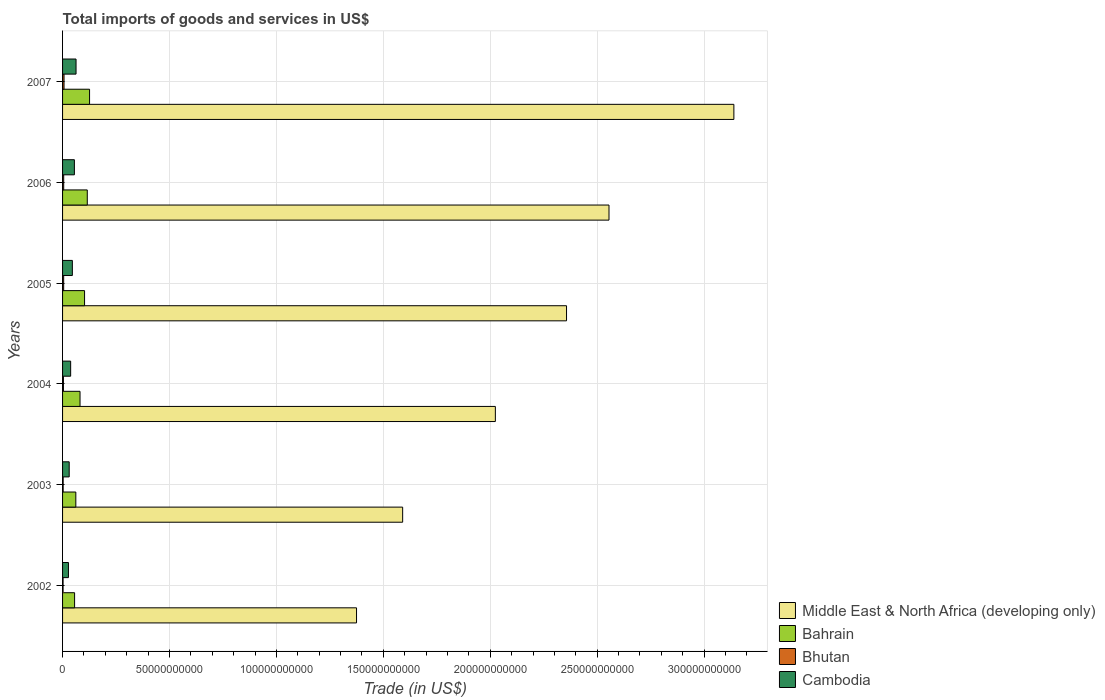How many different coloured bars are there?
Provide a succinct answer. 4. Are the number of bars on each tick of the Y-axis equal?
Your answer should be compact. Yes. How many bars are there on the 1st tick from the top?
Keep it short and to the point. 4. What is the label of the 3rd group of bars from the top?
Make the answer very short. 2005. In how many cases, is the number of bars for a given year not equal to the number of legend labels?
Your response must be concise. 0. What is the total imports of goods and services in Bahrain in 2003?
Offer a very short reply. 6.21e+09. Across all years, what is the maximum total imports of goods and services in Bhutan?
Provide a succinct answer. 6.85e+08. Across all years, what is the minimum total imports of goods and services in Bahrain?
Provide a succinct answer. 5.62e+09. In which year was the total imports of goods and services in Middle East & North Africa (developing only) maximum?
Offer a very short reply. 2007. What is the total total imports of goods and services in Middle East & North Africa (developing only) in the graph?
Your answer should be compact. 1.30e+12. What is the difference between the total imports of goods and services in Cambodia in 2005 and that in 2007?
Your answer should be very brief. -1.72e+09. What is the difference between the total imports of goods and services in Bahrain in 2006 and the total imports of goods and services in Cambodia in 2003?
Make the answer very short. 8.46e+09. What is the average total imports of goods and services in Bahrain per year?
Your answer should be very brief. 9.08e+09. In the year 2005, what is the difference between the total imports of goods and services in Bhutan and total imports of goods and services in Bahrain?
Offer a very short reply. -9.77e+09. What is the ratio of the total imports of goods and services in Cambodia in 2003 to that in 2005?
Ensure brevity in your answer.  0.68. Is the total imports of goods and services in Cambodia in 2002 less than that in 2003?
Provide a succinct answer. Yes. Is the difference between the total imports of goods and services in Bhutan in 2002 and 2006 greater than the difference between the total imports of goods and services in Bahrain in 2002 and 2006?
Your answer should be very brief. Yes. What is the difference between the highest and the second highest total imports of goods and services in Middle East & North Africa (developing only)?
Provide a succinct answer. 5.84e+1. What is the difference between the highest and the lowest total imports of goods and services in Bahrain?
Ensure brevity in your answer.  7.00e+09. In how many years, is the total imports of goods and services in Bhutan greater than the average total imports of goods and services in Bhutan taken over all years?
Provide a short and direct response. 3. Is the sum of the total imports of goods and services in Middle East & North Africa (developing only) in 2002 and 2006 greater than the maximum total imports of goods and services in Bhutan across all years?
Offer a very short reply. Yes. What does the 3rd bar from the top in 2006 represents?
Provide a short and direct response. Bahrain. What does the 1st bar from the bottom in 2006 represents?
Your response must be concise. Middle East & North Africa (developing only). Are all the bars in the graph horizontal?
Offer a very short reply. Yes. What is the difference between two consecutive major ticks on the X-axis?
Give a very brief answer. 5.00e+1. Are the values on the major ticks of X-axis written in scientific E-notation?
Ensure brevity in your answer.  No. Does the graph contain any zero values?
Your response must be concise. No. How many legend labels are there?
Give a very brief answer. 4. How are the legend labels stacked?
Your answer should be compact. Vertical. What is the title of the graph?
Your answer should be compact. Total imports of goods and services in US$. Does "Belarus" appear as one of the legend labels in the graph?
Your response must be concise. No. What is the label or title of the X-axis?
Provide a short and direct response. Trade (in US$). What is the Trade (in US$) of Middle East & North Africa (developing only) in 2002?
Give a very brief answer. 1.37e+11. What is the Trade (in US$) in Bahrain in 2002?
Your response must be concise. 5.62e+09. What is the Trade (in US$) in Bhutan in 2002?
Give a very brief answer. 2.40e+08. What is the Trade (in US$) of Cambodia in 2002?
Give a very brief answer. 2.75e+09. What is the Trade (in US$) of Middle East & North Africa (developing only) in 2003?
Offer a terse response. 1.59e+11. What is the Trade (in US$) of Bahrain in 2003?
Offer a terse response. 6.21e+09. What is the Trade (in US$) in Bhutan in 2003?
Provide a succinct answer. 2.75e+08. What is the Trade (in US$) of Cambodia in 2003?
Ensure brevity in your answer.  3.10e+09. What is the Trade (in US$) in Middle East & North Africa (developing only) in 2004?
Your answer should be very brief. 2.02e+11. What is the Trade (in US$) in Bahrain in 2004?
Give a very brief answer. 8.17e+09. What is the Trade (in US$) in Bhutan in 2004?
Your answer should be very brief. 4.06e+08. What is the Trade (in US$) of Cambodia in 2004?
Offer a terse response. 3.78e+09. What is the Trade (in US$) in Middle East & North Africa (developing only) in 2005?
Your answer should be compact. 2.36e+11. What is the Trade (in US$) of Bahrain in 2005?
Offer a terse response. 1.03e+1. What is the Trade (in US$) in Bhutan in 2005?
Offer a very short reply. 5.15e+08. What is the Trade (in US$) of Cambodia in 2005?
Give a very brief answer. 4.58e+09. What is the Trade (in US$) of Middle East & North Africa (developing only) in 2006?
Your response must be concise. 2.56e+11. What is the Trade (in US$) in Bahrain in 2006?
Your answer should be compact. 1.16e+1. What is the Trade (in US$) in Bhutan in 2006?
Provide a succinct answer. 5.31e+08. What is the Trade (in US$) in Cambodia in 2006?
Provide a succinct answer. 5.53e+09. What is the Trade (in US$) in Middle East & North Africa (developing only) in 2007?
Ensure brevity in your answer.  3.14e+11. What is the Trade (in US$) in Bahrain in 2007?
Make the answer very short. 1.26e+1. What is the Trade (in US$) of Bhutan in 2007?
Ensure brevity in your answer.  6.85e+08. What is the Trade (in US$) in Cambodia in 2007?
Your answer should be compact. 6.30e+09. Across all years, what is the maximum Trade (in US$) in Middle East & North Africa (developing only)?
Offer a very short reply. 3.14e+11. Across all years, what is the maximum Trade (in US$) in Bahrain?
Ensure brevity in your answer.  1.26e+1. Across all years, what is the maximum Trade (in US$) of Bhutan?
Offer a very short reply. 6.85e+08. Across all years, what is the maximum Trade (in US$) of Cambodia?
Keep it short and to the point. 6.30e+09. Across all years, what is the minimum Trade (in US$) of Middle East & North Africa (developing only)?
Your answer should be very brief. 1.37e+11. Across all years, what is the minimum Trade (in US$) in Bahrain?
Your response must be concise. 5.62e+09. Across all years, what is the minimum Trade (in US$) of Bhutan?
Give a very brief answer. 2.40e+08. Across all years, what is the minimum Trade (in US$) of Cambodia?
Keep it short and to the point. 2.75e+09. What is the total Trade (in US$) of Middle East & North Africa (developing only) in the graph?
Your answer should be very brief. 1.30e+12. What is the total Trade (in US$) of Bahrain in the graph?
Your response must be concise. 5.45e+1. What is the total Trade (in US$) of Bhutan in the graph?
Keep it short and to the point. 2.65e+09. What is the total Trade (in US$) of Cambodia in the graph?
Your answer should be very brief. 2.60e+1. What is the difference between the Trade (in US$) of Middle East & North Africa (developing only) in 2002 and that in 2003?
Offer a terse response. -2.16e+1. What is the difference between the Trade (in US$) in Bahrain in 2002 and that in 2003?
Offer a terse response. -5.81e+08. What is the difference between the Trade (in US$) of Bhutan in 2002 and that in 2003?
Offer a terse response. -3.50e+07. What is the difference between the Trade (in US$) of Cambodia in 2002 and that in 2003?
Make the answer very short. -3.47e+08. What is the difference between the Trade (in US$) in Middle East & North Africa (developing only) in 2002 and that in 2004?
Offer a terse response. -6.49e+1. What is the difference between the Trade (in US$) in Bahrain in 2002 and that in 2004?
Ensure brevity in your answer.  -2.55e+09. What is the difference between the Trade (in US$) in Bhutan in 2002 and that in 2004?
Offer a very short reply. -1.66e+08. What is the difference between the Trade (in US$) of Cambodia in 2002 and that in 2004?
Make the answer very short. -1.03e+09. What is the difference between the Trade (in US$) of Middle East & North Africa (developing only) in 2002 and that in 2005?
Keep it short and to the point. -9.82e+1. What is the difference between the Trade (in US$) in Bahrain in 2002 and that in 2005?
Your answer should be very brief. -4.66e+09. What is the difference between the Trade (in US$) in Bhutan in 2002 and that in 2005?
Offer a very short reply. -2.76e+08. What is the difference between the Trade (in US$) in Cambodia in 2002 and that in 2005?
Offer a terse response. -1.82e+09. What is the difference between the Trade (in US$) in Middle East & North Africa (developing only) in 2002 and that in 2006?
Your response must be concise. -1.18e+11. What is the difference between the Trade (in US$) in Bahrain in 2002 and that in 2006?
Offer a terse response. -5.93e+09. What is the difference between the Trade (in US$) in Bhutan in 2002 and that in 2006?
Keep it short and to the point. -2.92e+08. What is the difference between the Trade (in US$) in Cambodia in 2002 and that in 2006?
Keep it short and to the point. -2.78e+09. What is the difference between the Trade (in US$) in Middle East & North Africa (developing only) in 2002 and that in 2007?
Your response must be concise. -1.76e+11. What is the difference between the Trade (in US$) in Bahrain in 2002 and that in 2007?
Offer a terse response. -7.00e+09. What is the difference between the Trade (in US$) of Bhutan in 2002 and that in 2007?
Make the answer very short. -4.45e+08. What is the difference between the Trade (in US$) in Cambodia in 2002 and that in 2007?
Your response must be concise. -3.55e+09. What is the difference between the Trade (in US$) of Middle East & North Africa (developing only) in 2003 and that in 2004?
Make the answer very short. -4.34e+1. What is the difference between the Trade (in US$) in Bahrain in 2003 and that in 2004?
Your answer should be compact. -1.97e+09. What is the difference between the Trade (in US$) of Bhutan in 2003 and that in 2004?
Provide a succinct answer. -1.31e+08. What is the difference between the Trade (in US$) in Cambodia in 2003 and that in 2004?
Ensure brevity in your answer.  -6.84e+08. What is the difference between the Trade (in US$) in Middle East & North Africa (developing only) in 2003 and that in 2005?
Give a very brief answer. -7.66e+1. What is the difference between the Trade (in US$) of Bahrain in 2003 and that in 2005?
Your response must be concise. -4.08e+09. What is the difference between the Trade (in US$) in Bhutan in 2003 and that in 2005?
Your answer should be very brief. -2.41e+08. What is the difference between the Trade (in US$) in Cambodia in 2003 and that in 2005?
Offer a terse response. -1.48e+09. What is the difference between the Trade (in US$) in Middle East & North Africa (developing only) in 2003 and that in 2006?
Offer a very short reply. -9.65e+1. What is the difference between the Trade (in US$) of Bahrain in 2003 and that in 2006?
Provide a short and direct response. -5.35e+09. What is the difference between the Trade (in US$) of Bhutan in 2003 and that in 2006?
Provide a short and direct response. -2.57e+08. What is the difference between the Trade (in US$) of Cambodia in 2003 and that in 2006?
Offer a very short reply. -2.43e+09. What is the difference between the Trade (in US$) in Middle East & North Africa (developing only) in 2003 and that in 2007?
Keep it short and to the point. -1.55e+11. What is the difference between the Trade (in US$) in Bahrain in 2003 and that in 2007?
Provide a short and direct response. -6.42e+09. What is the difference between the Trade (in US$) of Bhutan in 2003 and that in 2007?
Give a very brief answer. -4.10e+08. What is the difference between the Trade (in US$) of Cambodia in 2003 and that in 2007?
Keep it short and to the point. -3.20e+09. What is the difference between the Trade (in US$) in Middle East & North Africa (developing only) in 2004 and that in 2005?
Give a very brief answer. -3.33e+1. What is the difference between the Trade (in US$) of Bahrain in 2004 and that in 2005?
Offer a terse response. -2.12e+09. What is the difference between the Trade (in US$) in Bhutan in 2004 and that in 2005?
Ensure brevity in your answer.  -1.09e+08. What is the difference between the Trade (in US$) of Cambodia in 2004 and that in 2005?
Ensure brevity in your answer.  -7.93e+08. What is the difference between the Trade (in US$) of Middle East & North Africa (developing only) in 2004 and that in 2006?
Make the answer very short. -5.31e+1. What is the difference between the Trade (in US$) in Bahrain in 2004 and that in 2006?
Keep it short and to the point. -3.39e+09. What is the difference between the Trade (in US$) in Bhutan in 2004 and that in 2006?
Give a very brief answer. -1.25e+08. What is the difference between the Trade (in US$) of Cambodia in 2004 and that in 2006?
Your answer should be compact. -1.75e+09. What is the difference between the Trade (in US$) in Middle East & North Africa (developing only) in 2004 and that in 2007?
Your response must be concise. -1.12e+11. What is the difference between the Trade (in US$) of Bahrain in 2004 and that in 2007?
Provide a short and direct response. -4.46e+09. What is the difference between the Trade (in US$) of Bhutan in 2004 and that in 2007?
Your answer should be very brief. -2.79e+08. What is the difference between the Trade (in US$) in Cambodia in 2004 and that in 2007?
Ensure brevity in your answer.  -2.52e+09. What is the difference between the Trade (in US$) in Middle East & North Africa (developing only) in 2005 and that in 2006?
Ensure brevity in your answer.  -1.99e+1. What is the difference between the Trade (in US$) of Bahrain in 2005 and that in 2006?
Your answer should be compact. -1.27e+09. What is the difference between the Trade (in US$) in Bhutan in 2005 and that in 2006?
Give a very brief answer. -1.60e+07. What is the difference between the Trade (in US$) in Cambodia in 2005 and that in 2006?
Offer a very short reply. -9.52e+08. What is the difference between the Trade (in US$) in Middle East & North Africa (developing only) in 2005 and that in 2007?
Provide a short and direct response. -7.83e+1. What is the difference between the Trade (in US$) of Bahrain in 2005 and that in 2007?
Offer a very short reply. -2.34e+09. What is the difference between the Trade (in US$) in Bhutan in 2005 and that in 2007?
Offer a very short reply. -1.70e+08. What is the difference between the Trade (in US$) in Cambodia in 2005 and that in 2007?
Your answer should be compact. -1.72e+09. What is the difference between the Trade (in US$) of Middle East & North Africa (developing only) in 2006 and that in 2007?
Make the answer very short. -5.84e+1. What is the difference between the Trade (in US$) in Bahrain in 2006 and that in 2007?
Offer a very short reply. -1.07e+09. What is the difference between the Trade (in US$) in Bhutan in 2006 and that in 2007?
Keep it short and to the point. -1.54e+08. What is the difference between the Trade (in US$) of Cambodia in 2006 and that in 2007?
Offer a terse response. -7.71e+08. What is the difference between the Trade (in US$) in Middle East & North Africa (developing only) in 2002 and the Trade (in US$) in Bahrain in 2003?
Ensure brevity in your answer.  1.31e+11. What is the difference between the Trade (in US$) of Middle East & North Africa (developing only) in 2002 and the Trade (in US$) of Bhutan in 2003?
Keep it short and to the point. 1.37e+11. What is the difference between the Trade (in US$) of Middle East & North Africa (developing only) in 2002 and the Trade (in US$) of Cambodia in 2003?
Offer a terse response. 1.34e+11. What is the difference between the Trade (in US$) in Bahrain in 2002 and the Trade (in US$) in Bhutan in 2003?
Provide a succinct answer. 5.35e+09. What is the difference between the Trade (in US$) of Bahrain in 2002 and the Trade (in US$) of Cambodia in 2003?
Offer a very short reply. 2.52e+09. What is the difference between the Trade (in US$) in Bhutan in 2002 and the Trade (in US$) in Cambodia in 2003?
Offer a terse response. -2.86e+09. What is the difference between the Trade (in US$) of Middle East & North Africa (developing only) in 2002 and the Trade (in US$) of Bahrain in 2004?
Your answer should be compact. 1.29e+11. What is the difference between the Trade (in US$) of Middle East & North Africa (developing only) in 2002 and the Trade (in US$) of Bhutan in 2004?
Offer a terse response. 1.37e+11. What is the difference between the Trade (in US$) of Middle East & North Africa (developing only) in 2002 and the Trade (in US$) of Cambodia in 2004?
Ensure brevity in your answer.  1.34e+11. What is the difference between the Trade (in US$) in Bahrain in 2002 and the Trade (in US$) in Bhutan in 2004?
Your response must be concise. 5.22e+09. What is the difference between the Trade (in US$) in Bahrain in 2002 and the Trade (in US$) in Cambodia in 2004?
Make the answer very short. 1.84e+09. What is the difference between the Trade (in US$) of Bhutan in 2002 and the Trade (in US$) of Cambodia in 2004?
Provide a short and direct response. -3.55e+09. What is the difference between the Trade (in US$) in Middle East & North Africa (developing only) in 2002 and the Trade (in US$) in Bahrain in 2005?
Offer a very short reply. 1.27e+11. What is the difference between the Trade (in US$) in Middle East & North Africa (developing only) in 2002 and the Trade (in US$) in Bhutan in 2005?
Give a very brief answer. 1.37e+11. What is the difference between the Trade (in US$) in Middle East & North Africa (developing only) in 2002 and the Trade (in US$) in Cambodia in 2005?
Make the answer very short. 1.33e+11. What is the difference between the Trade (in US$) of Bahrain in 2002 and the Trade (in US$) of Bhutan in 2005?
Your response must be concise. 5.11e+09. What is the difference between the Trade (in US$) of Bahrain in 2002 and the Trade (in US$) of Cambodia in 2005?
Your response must be concise. 1.05e+09. What is the difference between the Trade (in US$) of Bhutan in 2002 and the Trade (in US$) of Cambodia in 2005?
Provide a succinct answer. -4.34e+09. What is the difference between the Trade (in US$) in Middle East & North Africa (developing only) in 2002 and the Trade (in US$) in Bahrain in 2006?
Offer a very short reply. 1.26e+11. What is the difference between the Trade (in US$) of Middle East & North Africa (developing only) in 2002 and the Trade (in US$) of Bhutan in 2006?
Offer a very short reply. 1.37e+11. What is the difference between the Trade (in US$) of Middle East & North Africa (developing only) in 2002 and the Trade (in US$) of Cambodia in 2006?
Provide a short and direct response. 1.32e+11. What is the difference between the Trade (in US$) in Bahrain in 2002 and the Trade (in US$) in Bhutan in 2006?
Your answer should be very brief. 5.09e+09. What is the difference between the Trade (in US$) of Bahrain in 2002 and the Trade (in US$) of Cambodia in 2006?
Offer a terse response. 9.40e+07. What is the difference between the Trade (in US$) of Bhutan in 2002 and the Trade (in US$) of Cambodia in 2006?
Offer a terse response. -5.29e+09. What is the difference between the Trade (in US$) of Middle East & North Africa (developing only) in 2002 and the Trade (in US$) of Bahrain in 2007?
Make the answer very short. 1.25e+11. What is the difference between the Trade (in US$) in Middle East & North Africa (developing only) in 2002 and the Trade (in US$) in Bhutan in 2007?
Offer a very short reply. 1.37e+11. What is the difference between the Trade (in US$) of Middle East & North Africa (developing only) in 2002 and the Trade (in US$) of Cambodia in 2007?
Give a very brief answer. 1.31e+11. What is the difference between the Trade (in US$) in Bahrain in 2002 and the Trade (in US$) in Bhutan in 2007?
Your response must be concise. 4.94e+09. What is the difference between the Trade (in US$) in Bahrain in 2002 and the Trade (in US$) in Cambodia in 2007?
Ensure brevity in your answer.  -6.77e+08. What is the difference between the Trade (in US$) in Bhutan in 2002 and the Trade (in US$) in Cambodia in 2007?
Your response must be concise. -6.06e+09. What is the difference between the Trade (in US$) in Middle East & North Africa (developing only) in 2003 and the Trade (in US$) in Bahrain in 2004?
Your answer should be compact. 1.51e+11. What is the difference between the Trade (in US$) in Middle East & North Africa (developing only) in 2003 and the Trade (in US$) in Bhutan in 2004?
Keep it short and to the point. 1.59e+11. What is the difference between the Trade (in US$) of Middle East & North Africa (developing only) in 2003 and the Trade (in US$) of Cambodia in 2004?
Offer a very short reply. 1.55e+11. What is the difference between the Trade (in US$) of Bahrain in 2003 and the Trade (in US$) of Bhutan in 2004?
Keep it short and to the point. 5.80e+09. What is the difference between the Trade (in US$) of Bahrain in 2003 and the Trade (in US$) of Cambodia in 2004?
Your answer should be very brief. 2.42e+09. What is the difference between the Trade (in US$) in Bhutan in 2003 and the Trade (in US$) in Cambodia in 2004?
Keep it short and to the point. -3.51e+09. What is the difference between the Trade (in US$) of Middle East & North Africa (developing only) in 2003 and the Trade (in US$) of Bahrain in 2005?
Make the answer very short. 1.49e+11. What is the difference between the Trade (in US$) of Middle East & North Africa (developing only) in 2003 and the Trade (in US$) of Bhutan in 2005?
Provide a short and direct response. 1.59e+11. What is the difference between the Trade (in US$) in Middle East & North Africa (developing only) in 2003 and the Trade (in US$) in Cambodia in 2005?
Offer a very short reply. 1.54e+11. What is the difference between the Trade (in US$) of Bahrain in 2003 and the Trade (in US$) of Bhutan in 2005?
Provide a short and direct response. 5.69e+09. What is the difference between the Trade (in US$) of Bahrain in 2003 and the Trade (in US$) of Cambodia in 2005?
Make the answer very short. 1.63e+09. What is the difference between the Trade (in US$) in Bhutan in 2003 and the Trade (in US$) in Cambodia in 2005?
Keep it short and to the point. -4.30e+09. What is the difference between the Trade (in US$) of Middle East & North Africa (developing only) in 2003 and the Trade (in US$) of Bahrain in 2006?
Your answer should be compact. 1.47e+11. What is the difference between the Trade (in US$) of Middle East & North Africa (developing only) in 2003 and the Trade (in US$) of Bhutan in 2006?
Offer a terse response. 1.59e+11. What is the difference between the Trade (in US$) in Middle East & North Africa (developing only) in 2003 and the Trade (in US$) in Cambodia in 2006?
Provide a succinct answer. 1.54e+11. What is the difference between the Trade (in US$) of Bahrain in 2003 and the Trade (in US$) of Bhutan in 2006?
Ensure brevity in your answer.  5.67e+09. What is the difference between the Trade (in US$) of Bahrain in 2003 and the Trade (in US$) of Cambodia in 2006?
Offer a terse response. 6.75e+08. What is the difference between the Trade (in US$) of Bhutan in 2003 and the Trade (in US$) of Cambodia in 2006?
Your answer should be very brief. -5.26e+09. What is the difference between the Trade (in US$) in Middle East & North Africa (developing only) in 2003 and the Trade (in US$) in Bahrain in 2007?
Your answer should be compact. 1.46e+11. What is the difference between the Trade (in US$) in Middle East & North Africa (developing only) in 2003 and the Trade (in US$) in Bhutan in 2007?
Provide a succinct answer. 1.58e+11. What is the difference between the Trade (in US$) of Middle East & North Africa (developing only) in 2003 and the Trade (in US$) of Cambodia in 2007?
Ensure brevity in your answer.  1.53e+11. What is the difference between the Trade (in US$) of Bahrain in 2003 and the Trade (in US$) of Bhutan in 2007?
Offer a terse response. 5.52e+09. What is the difference between the Trade (in US$) of Bahrain in 2003 and the Trade (in US$) of Cambodia in 2007?
Your answer should be very brief. -9.66e+07. What is the difference between the Trade (in US$) in Bhutan in 2003 and the Trade (in US$) in Cambodia in 2007?
Keep it short and to the point. -6.03e+09. What is the difference between the Trade (in US$) of Middle East & North Africa (developing only) in 2004 and the Trade (in US$) of Bahrain in 2005?
Your answer should be very brief. 1.92e+11. What is the difference between the Trade (in US$) in Middle East & North Africa (developing only) in 2004 and the Trade (in US$) in Bhutan in 2005?
Your answer should be compact. 2.02e+11. What is the difference between the Trade (in US$) in Middle East & North Africa (developing only) in 2004 and the Trade (in US$) in Cambodia in 2005?
Offer a very short reply. 1.98e+11. What is the difference between the Trade (in US$) in Bahrain in 2004 and the Trade (in US$) in Bhutan in 2005?
Make the answer very short. 7.66e+09. What is the difference between the Trade (in US$) in Bahrain in 2004 and the Trade (in US$) in Cambodia in 2005?
Make the answer very short. 3.59e+09. What is the difference between the Trade (in US$) of Bhutan in 2004 and the Trade (in US$) of Cambodia in 2005?
Keep it short and to the point. -4.17e+09. What is the difference between the Trade (in US$) in Middle East & North Africa (developing only) in 2004 and the Trade (in US$) in Bahrain in 2006?
Make the answer very short. 1.91e+11. What is the difference between the Trade (in US$) of Middle East & North Africa (developing only) in 2004 and the Trade (in US$) of Bhutan in 2006?
Your response must be concise. 2.02e+11. What is the difference between the Trade (in US$) of Middle East & North Africa (developing only) in 2004 and the Trade (in US$) of Cambodia in 2006?
Give a very brief answer. 1.97e+11. What is the difference between the Trade (in US$) of Bahrain in 2004 and the Trade (in US$) of Bhutan in 2006?
Your answer should be very brief. 7.64e+09. What is the difference between the Trade (in US$) in Bahrain in 2004 and the Trade (in US$) in Cambodia in 2006?
Offer a very short reply. 2.64e+09. What is the difference between the Trade (in US$) in Bhutan in 2004 and the Trade (in US$) in Cambodia in 2006?
Offer a terse response. -5.12e+09. What is the difference between the Trade (in US$) in Middle East & North Africa (developing only) in 2004 and the Trade (in US$) in Bahrain in 2007?
Make the answer very short. 1.90e+11. What is the difference between the Trade (in US$) in Middle East & North Africa (developing only) in 2004 and the Trade (in US$) in Bhutan in 2007?
Your answer should be compact. 2.02e+11. What is the difference between the Trade (in US$) of Middle East & North Africa (developing only) in 2004 and the Trade (in US$) of Cambodia in 2007?
Give a very brief answer. 1.96e+11. What is the difference between the Trade (in US$) of Bahrain in 2004 and the Trade (in US$) of Bhutan in 2007?
Offer a very short reply. 7.49e+09. What is the difference between the Trade (in US$) of Bahrain in 2004 and the Trade (in US$) of Cambodia in 2007?
Your response must be concise. 1.87e+09. What is the difference between the Trade (in US$) of Bhutan in 2004 and the Trade (in US$) of Cambodia in 2007?
Make the answer very short. -5.90e+09. What is the difference between the Trade (in US$) of Middle East & North Africa (developing only) in 2005 and the Trade (in US$) of Bahrain in 2006?
Ensure brevity in your answer.  2.24e+11. What is the difference between the Trade (in US$) of Middle East & North Africa (developing only) in 2005 and the Trade (in US$) of Bhutan in 2006?
Make the answer very short. 2.35e+11. What is the difference between the Trade (in US$) in Middle East & North Africa (developing only) in 2005 and the Trade (in US$) in Cambodia in 2006?
Offer a very short reply. 2.30e+11. What is the difference between the Trade (in US$) in Bahrain in 2005 and the Trade (in US$) in Bhutan in 2006?
Your response must be concise. 9.76e+09. What is the difference between the Trade (in US$) of Bahrain in 2005 and the Trade (in US$) of Cambodia in 2006?
Provide a succinct answer. 4.76e+09. What is the difference between the Trade (in US$) of Bhutan in 2005 and the Trade (in US$) of Cambodia in 2006?
Make the answer very short. -5.01e+09. What is the difference between the Trade (in US$) in Middle East & North Africa (developing only) in 2005 and the Trade (in US$) in Bahrain in 2007?
Provide a succinct answer. 2.23e+11. What is the difference between the Trade (in US$) in Middle East & North Africa (developing only) in 2005 and the Trade (in US$) in Bhutan in 2007?
Make the answer very short. 2.35e+11. What is the difference between the Trade (in US$) in Middle East & North Africa (developing only) in 2005 and the Trade (in US$) in Cambodia in 2007?
Offer a very short reply. 2.29e+11. What is the difference between the Trade (in US$) of Bahrain in 2005 and the Trade (in US$) of Bhutan in 2007?
Give a very brief answer. 9.60e+09. What is the difference between the Trade (in US$) of Bahrain in 2005 and the Trade (in US$) of Cambodia in 2007?
Offer a very short reply. 3.99e+09. What is the difference between the Trade (in US$) of Bhutan in 2005 and the Trade (in US$) of Cambodia in 2007?
Offer a terse response. -5.79e+09. What is the difference between the Trade (in US$) in Middle East & North Africa (developing only) in 2006 and the Trade (in US$) in Bahrain in 2007?
Your answer should be compact. 2.43e+11. What is the difference between the Trade (in US$) of Middle East & North Africa (developing only) in 2006 and the Trade (in US$) of Bhutan in 2007?
Offer a very short reply. 2.55e+11. What is the difference between the Trade (in US$) of Middle East & North Africa (developing only) in 2006 and the Trade (in US$) of Cambodia in 2007?
Provide a short and direct response. 2.49e+11. What is the difference between the Trade (in US$) of Bahrain in 2006 and the Trade (in US$) of Bhutan in 2007?
Ensure brevity in your answer.  1.09e+1. What is the difference between the Trade (in US$) in Bahrain in 2006 and the Trade (in US$) in Cambodia in 2007?
Offer a terse response. 5.26e+09. What is the difference between the Trade (in US$) in Bhutan in 2006 and the Trade (in US$) in Cambodia in 2007?
Offer a very short reply. -5.77e+09. What is the average Trade (in US$) of Middle East & North Africa (developing only) per year?
Offer a terse response. 2.17e+11. What is the average Trade (in US$) in Bahrain per year?
Offer a terse response. 9.08e+09. What is the average Trade (in US$) of Bhutan per year?
Give a very brief answer. 4.42e+08. What is the average Trade (in US$) in Cambodia per year?
Your answer should be very brief. 4.34e+09. In the year 2002, what is the difference between the Trade (in US$) in Middle East & North Africa (developing only) and Trade (in US$) in Bahrain?
Keep it short and to the point. 1.32e+11. In the year 2002, what is the difference between the Trade (in US$) in Middle East & North Africa (developing only) and Trade (in US$) in Bhutan?
Your answer should be compact. 1.37e+11. In the year 2002, what is the difference between the Trade (in US$) of Middle East & North Africa (developing only) and Trade (in US$) of Cambodia?
Provide a succinct answer. 1.35e+11. In the year 2002, what is the difference between the Trade (in US$) in Bahrain and Trade (in US$) in Bhutan?
Ensure brevity in your answer.  5.38e+09. In the year 2002, what is the difference between the Trade (in US$) of Bahrain and Trade (in US$) of Cambodia?
Ensure brevity in your answer.  2.87e+09. In the year 2002, what is the difference between the Trade (in US$) in Bhutan and Trade (in US$) in Cambodia?
Ensure brevity in your answer.  -2.51e+09. In the year 2003, what is the difference between the Trade (in US$) of Middle East & North Africa (developing only) and Trade (in US$) of Bahrain?
Provide a succinct answer. 1.53e+11. In the year 2003, what is the difference between the Trade (in US$) in Middle East & North Africa (developing only) and Trade (in US$) in Bhutan?
Your answer should be very brief. 1.59e+11. In the year 2003, what is the difference between the Trade (in US$) in Middle East & North Africa (developing only) and Trade (in US$) in Cambodia?
Give a very brief answer. 1.56e+11. In the year 2003, what is the difference between the Trade (in US$) of Bahrain and Trade (in US$) of Bhutan?
Your response must be concise. 5.93e+09. In the year 2003, what is the difference between the Trade (in US$) in Bahrain and Trade (in US$) in Cambodia?
Keep it short and to the point. 3.10e+09. In the year 2003, what is the difference between the Trade (in US$) of Bhutan and Trade (in US$) of Cambodia?
Offer a terse response. -2.83e+09. In the year 2004, what is the difference between the Trade (in US$) in Middle East & North Africa (developing only) and Trade (in US$) in Bahrain?
Your answer should be compact. 1.94e+11. In the year 2004, what is the difference between the Trade (in US$) of Middle East & North Africa (developing only) and Trade (in US$) of Bhutan?
Your response must be concise. 2.02e+11. In the year 2004, what is the difference between the Trade (in US$) of Middle East & North Africa (developing only) and Trade (in US$) of Cambodia?
Your answer should be compact. 1.99e+11. In the year 2004, what is the difference between the Trade (in US$) of Bahrain and Trade (in US$) of Bhutan?
Your answer should be compact. 7.76e+09. In the year 2004, what is the difference between the Trade (in US$) of Bahrain and Trade (in US$) of Cambodia?
Your answer should be compact. 4.39e+09. In the year 2004, what is the difference between the Trade (in US$) of Bhutan and Trade (in US$) of Cambodia?
Offer a terse response. -3.38e+09. In the year 2005, what is the difference between the Trade (in US$) of Middle East & North Africa (developing only) and Trade (in US$) of Bahrain?
Your answer should be compact. 2.25e+11. In the year 2005, what is the difference between the Trade (in US$) of Middle East & North Africa (developing only) and Trade (in US$) of Bhutan?
Your response must be concise. 2.35e+11. In the year 2005, what is the difference between the Trade (in US$) in Middle East & North Africa (developing only) and Trade (in US$) in Cambodia?
Offer a very short reply. 2.31e+11. In the year 2005, what is the difference between the Trade (in US$) of Bahrain and Trade (in US$) of Bhutan?
Offer a terse response. 9.77e+09. In the year 2005, what is the difference between the Trade (in US$) of Bahrain and Trade (in US$) of Cambodia?
Make the answer very short. 5.71e+09. In the year 2005, what is the difference between the Trade (in US$) in Bhutan and Trade (in US$) in Cambodia?
Make the answer very short. -4.06e+09. In the year 2006, what is the difference between the Trade (in US$) of Middle East & North Africa (developing only) and Trade (in US$) of Bahrain?
Your answer should be compact. 2.44e+11. In the year 2006, what is the difference between the Trade (in US$) in Middle East & North Africa (developing only) and Trade (in US$) in Bhutan?
Make the answer very short. 2.55e+11. In the year 2006, what is the difference between the Trade (in US$) of Middle East & North Africa (developing only) and Trade (in US$) of Cambodia?
Ensure brevity in your answer.  2.50e+11. In the year 2006, what is the difference between the Trade (in US$) of Bahrain and Trade (in US$) of Bhutan?
Make the answer very short. 1.10e+1. In the year 2006, what is the difference between the Trade (in US$) in Bahrain and Trade (in US$) in Cambodia?
Keep it short and to the point. 6.03e+09. In the year 2006, what is the difference between the Trade (in US$) in Bhutan and Trade (in US$) in Cambodia?
Provide a short and direct response. -5.00e+09. In the year 2007, what is the difference between the Trade (in US$) of Middle East & North Africa (developing only) and Trade (in US$) of Bahrain?
Offer a terse response. 3.01e+11. In the year 2007, what is the difference between the Trade (in US$) in Middle East & North Africa (developing only) and Trade (in US$) in Bhutan?
Keep it short and to the point. 3.13e+11. In the year 2007, what is the difference between the Trade (in US$) in Middle East & North Africa (developing only) and Trade (in US$) in Cambodia?
Give a very brief answer. 3.08e+11. In the year 2007, what is the difference between the Trade (in US$) in Bahrain and Trade (in US$) in Bhutan?
Your answer should be very brief. 1.19e+1. In the year 2007, what is the difference between the Trade (in US$) of Bahrain and Trade (in US$) of Cambodia?
Offer a terse response. 6.32e+09. In the year 2007, what is the difference between the Trade (in US$) of Bhutan and Trade (in US$) of Cambodia?
Provide a succinct answer. -5.62e+09. What is the ratio of the Trade (in US$) in Middle East & North Africa (developing only) in 2002 to that in 2003?
Provide a succinct answer. 0.86. What is the ratio of the Trade (in US$) in Bahrain in 2002 to that in 2003?
Offer a very short reply. 0.91. What is the ratio of the Trade (in US$) of Bhutan in 2002 to that in 2003?
Provide a short and direct response. 0.87. What is the ratio of the Trade (in US$) of Cambodia in 2002 to that in 2003?
Your response must be concise. 0.89. What is the ratio of the Trade (in US$) in Middle East & North Africa (developing only) in 2002 to that in 2004?
Ensure brevity in your answer.  0.68. What is the ratio of the Trade (in US$) of Bahrain in 2002 to that in 2004?
Provide a succinct answer. 0.69. What is the ratio of the Trade (in US$) of Bhutan in 2002 to that in 2004?
Ensure brevity in your answer.  0.59. What is the ratio of the Trade (in US$) in Cambodia in 2002 to that in 2004?
Your answer should be compact. 0.73. What is the ratio of the Trade (in US$) in Middle East & North Africa (developing only) in 2002 to that in 2005?
Ensure brevity in your answer.  0.58. What is the ratio of the Trade (in US$) of Bahrain in 2002 to that in 2005?
Keep it short and to the point. 0.55. What is the ratio of the Trade (in US$) of Bhutan in 2002 to that in 2005?
Provide a succinct answer. 0.47. What is the ratio of the Trade (in US$) in Cambodia in 2002 to that in 2005?
Your answer should be very brief. 0.6. What is the ratio of the Trade (in US$) of Middle East & North Africa (developing only) in 2002 to that in 2006?
Keep it short and to the point. 0.54. What is the ratio of the Trade (in US$) of Bahrain in 2002 to that in 2006?
Your answer should be compact. 0.49. What is the ratio of the Trade (in US$) in Bhutan in 2002 to that in 2006?
Offer a very short reply. 0.45. What is the ratio of the Trade (in US$) in Cambodia in 2002 to that in 2006?
Your answer should be very brief. 0.5. What is the ratio of the Trade (in US$) in Middle East & North Africa (developing only) in 2002 to that in 2007?
Keep it short and to the point. 0.44. What is the ratio of the Trade (in US$) of Bahrain in 2002 to that in 2007?
Provide a succinct answer. 0.45. What is the ratio of the Trade (in US$) in Bhutan in 2002 to that in 2007?
Your answer should be compact. 0.35. What is the ratio of the Trade (in US$) of Cambodia in 2002 to that in 2007?
Your answer should be very brief. 0.44. What is the ratio of the Trade (in US$) in Middle East & North Africa (developing only) in 2003 to that in 2004?
Offer a terse response. 0.79. What is the ratio of the Trade (in US$) in Bahrain in 2003 to that in 2004?
Offer a terse response. 0.76. What is the ratio of the Trade (in US$) in Bhutan in 2003 to that in 2004?
Give a very brief answer. 0.68. What is the ratio of the Trade (in US$) in Cambodia in 2003 to that in 2004?
Provide a short and direct response. 0.82. What is the ratio of the Trade (in US$) of Middle East & North Africa (developing only) in 2003 to that in 2005?
Provide a short and direct response. 0.67. What is the ratio of the Trade (in US$) in Bahrain in 2003 to that in 2005?
Provide a short and direct response. 0.6. What is the ratio of the Trade (in US$) in Bhutan in 2003 to that in 2005?
Ensure brevity in your answer.  0.53. What is the ratio of the Trade (in US$) in Cambodia in 2003 to that in 2005?
Your answer should be very brief. 0.68. What is the ratio of the Trade (in US$) in Middle East & North Africa (developing only) in 2003 to that in 2006?
Ensure brevity in your answer.  0.62. What is the ratio of the Trade (in US$) in Bahrain in 2003 to that in 2006?
Provide a short and direct response. 0.54. What is the ratio of the Trade (in US$) of Bhutan in 2003 to that in 2006?
Offer a very short reply. 0.52. What is the ratio of the Trade (in US$) in Cambodia in 2003 to that in 2006?
Offer a very short reply. 0.56. What is the ratio of the Trade (in US$) in Middle East & North Africa (developing only) in 2003 to that in 2007?
Your response must be concise. 0.51. What is the ratio of the Trade (in US$) of Bahrain in 2003 to that in 2007?
Make the answer very short. 0.49. What is the ratio of the Trade (in US$) in Bhutan in 2003 to that in 2007?
Provide a succinct answer. 0.4. What is the ratio of the Trade (in US$) in Cambodia in 2003 to that in 2007?
Provide a short and direct response. 0.49. What is the ratio of the Trade (in US$) of Middle East & North Africa (developing only) in 2004 to that in 2005?
Make the answer very short. 0.86. What is the ratio of the Trade (in US$) in Bahrain in 2004 to that in 2005?
Make the answer very short. 0.79. What is the ratio of the Trade (in US$) of Bhutan in 2004 to that in 2005?
Your answer should be compact. 0.79. What is the ratio of the Trade (in US$) of Cambodia in 2004 to that in 2005?
Offer a terse response. 0.83. What is the ratio of the Trade (in US$) in Middle East & North Africa (developing only) in 2004 to that in 2006?
Ensure brevity in your answer.  0.79. What is the ratio of the Trade (in US$) in Bahrain in 2004 to that in 2006?
Provide a short and direct response. 0.71. What is the ratio of the Trade (in US$) of Bhutan in 2004 to that in 2006?
Provide a short and direct response. 0.76. What is the ratio of the Trade (in US$) in Cambodia in 2004 to that in 2006?
Your answer should be compact. 0.68. What is the ratio of the Trade (in US$) in Middle East & North Africa (developing only) in 2004 to that in 2007?
Give a very brief answer. 0.64. What is the ratio of the Trade (in US$) in Bahrain in 2004 to that in 2007?
Provide a short and direct response. 0.65. What is the ratio of the Trade (in US$) of Bhutan in 2004 to that in 2007?
Provide a short and direct response. 0.59. What is the ratio of the Trade (in US$) in Cambodia in 2004 to that in 2007?
Offer a very short reply. 0.6. What is the ratio of the Trade (in US$) in Middle East & North Africa (developing only) in 2005 to that in 2006?
Your answer should be compact. 0.92. What is the ratio of the Trade (in US$) of Bahrain in 2005 to that in 2006?
Provide a succinct answer. 0.89. What is the ratio of the Trade (in US$) of Bhutan in 2005 to that in 2006?
Provide a succinct answer. 0.97. What is the ratio of the Trade (in US$) of Cambodia in 2005 to that in 2006?
Provide a short and direct response. 0.83. What is the ratio of the Trade (in US$) in Middle East & North Africa (developing only) in 2005 to that in 2007?
Keep it short and to the point. 0.75. What is the ratio of the Trade (in US$) in Bahrain in 2005 to that in 2007?
Your answer should be very brief. 0.81. What is the ratio of the Trade (in US$) of Bhutan in 2005 to that in 2007?
Offer a very short reply. 0.75. What is the ratio of the Trade (in US$) of Cambodia in 2005 to that in 2007?
Give a very brief answer. 0.73. What is the ratio of the Trade (in US$) of Middle East & North Africa (developing only) in 2006 to that in 2007?
Ensure brevity in your answer.  0.81. What is the ratio of the Trade (in US$) of Bahrain in 2006 to that in 2007?
Keep it short and to the point. 0.92. What is the ratio of the Trade (in US$) of Bhutan in 2006 to that in 2007?
Provide a short and direct response. 0.78. What is the ratio of the Trade (in US$) in Cambodia in 2006 to that in 2007?
Your answer should be very brief. 0.88. What is the difference between the highest and the second highest Trade (in US$) in Middle East & North Africa (developing only)?
Give a very brief answer. 5.84e+1. What is the difference between the highest and the second highest Trade (in US$) of Bahrain?
Give a very brief answer. 1.07e+09. What is the difference between the highest and the second highest Trade (in US$) of Bhutan?
Your response must be concise. 1.54e+08. What is the difference between the highest and the second highest Trade (in US$) of Cambodia?
Offer a very short reply. 7.71e+08. What is the difference between the highest and the lowest Trade (in US$) in Middle East & North Africa (developing only)?
Offer a terse response. 1.76e+11. What is the difference between the highest and the lowest Trade (in US$) in Bahrain?
Provide a short and direct response. 7.00e+09. What is the difference between the highest and the lowest Trade (in US$) of Bhutan?
Provide a short and direct response. 4.45e+08. What is the difference between the highest and the lowest Trade (in US$) of Cambodia?
Keep it short and to the point. 3.55e+09. 